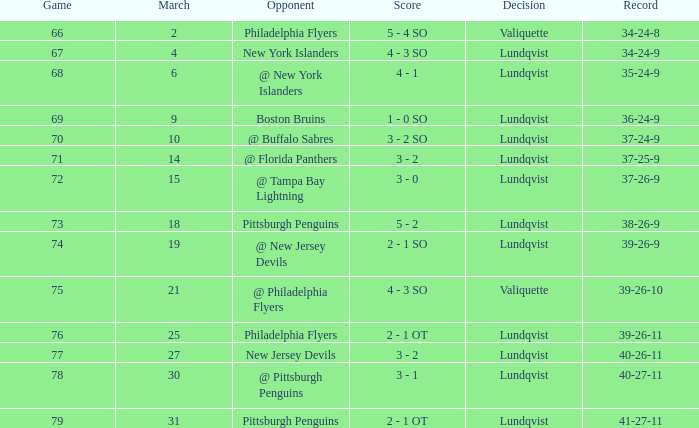Which opponent's march was 31? Pittsburgh Penguins. 